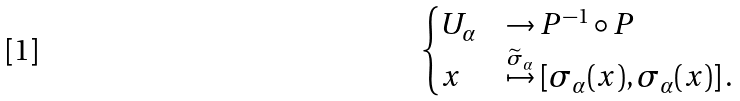Convert formula to latex. <formula><loc_0><loc_0><loc_500><loc_500>\begin{cases} U _ { \alpha } & \to P ^ { - 1 } \circ P \\ x & \overset { \widetilde { \sigma } _ { \alpha } } \mapsto \left [ \sigma _ { \alpha } ( x ) , \sigma _ { \alpha } ( x ) \right ] . \end{cases}</formula> 